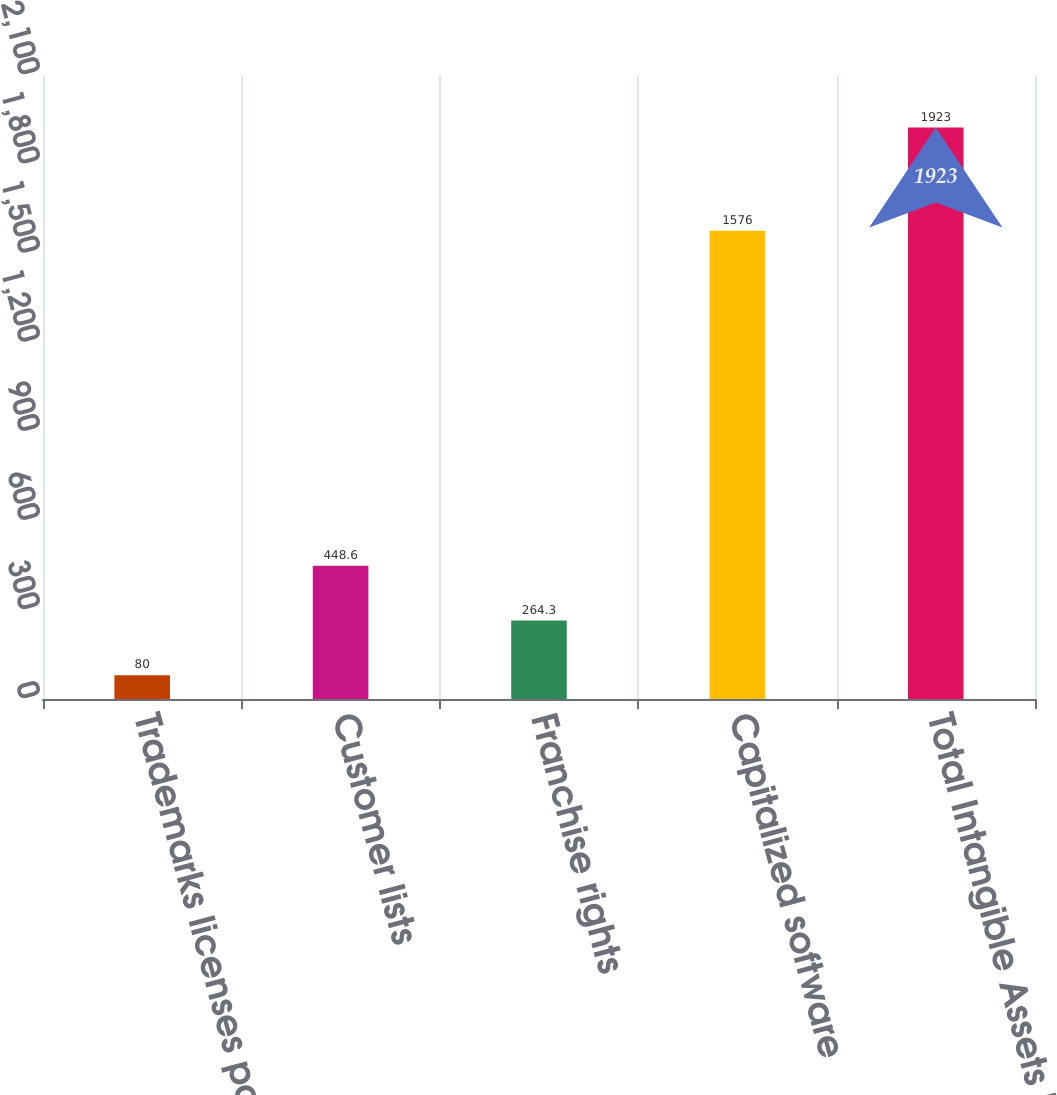Convert chart to OTSL. <chart><loc_0><loc_0><loc_500><loc_500><bar_chart><fcel>Trademarks licenses patents<fcel>Customer lists<fcel>Franchise rights<fcel>Capitalized software<fcel>Total Intangible Assets Net<nl><fcel>80<fcel>448.6<fcel>264.3<fcel>1576<fcel>1923<nl></chart> 